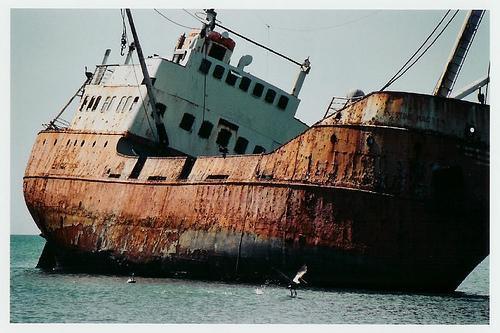How many shark fins are visible in the water in front of the ship?
Give a very brief answer. 0. 